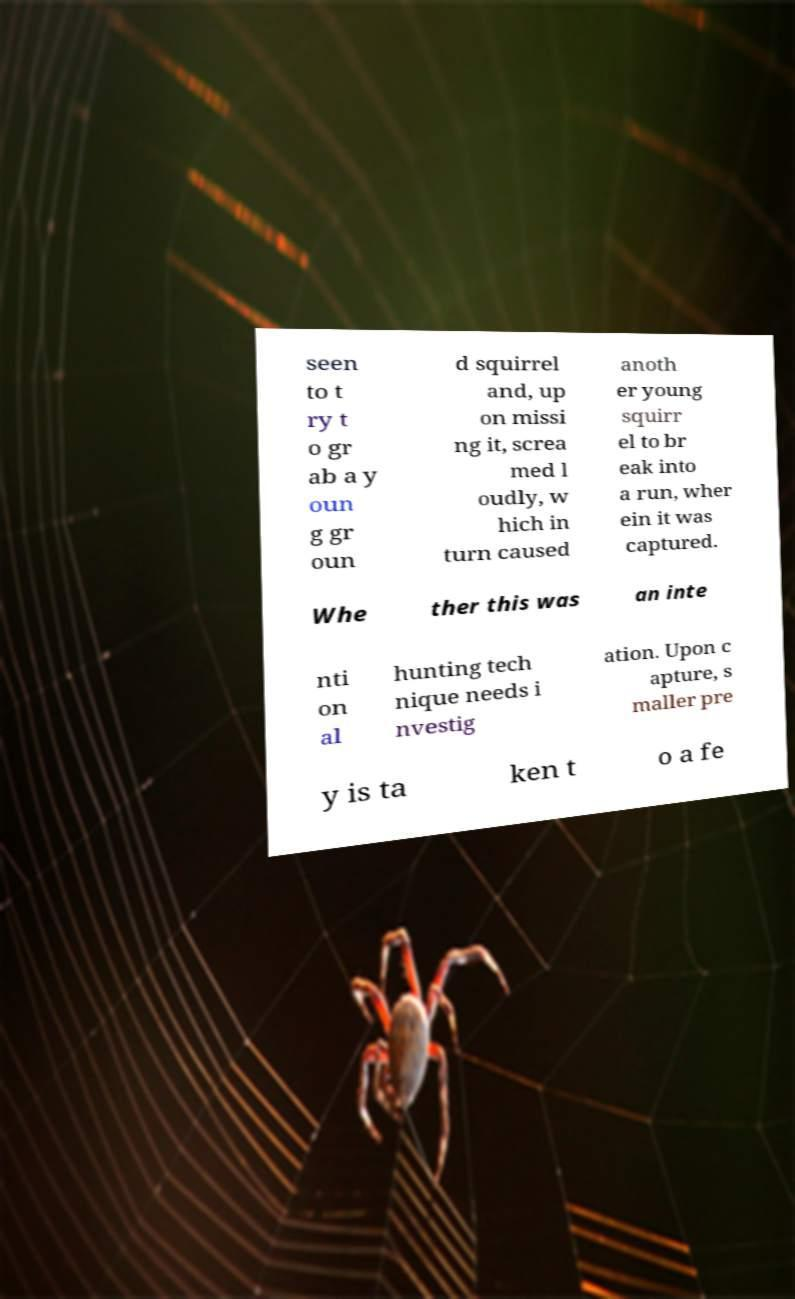I need the written content from this picture converted into text. Can you do that? seen to t ry t o gr ab a y oun g gr oun d squirrel and, up on missi ng it, screa med l oudly, w hich in turn caused anoth er young squirr el to br eak into a run, wher ein it was captured. Whe ther this was an inte nti on al hunting tech nique needs i nvestig ation. Upon c apture, s maller pre y is ta ken t o a fe 